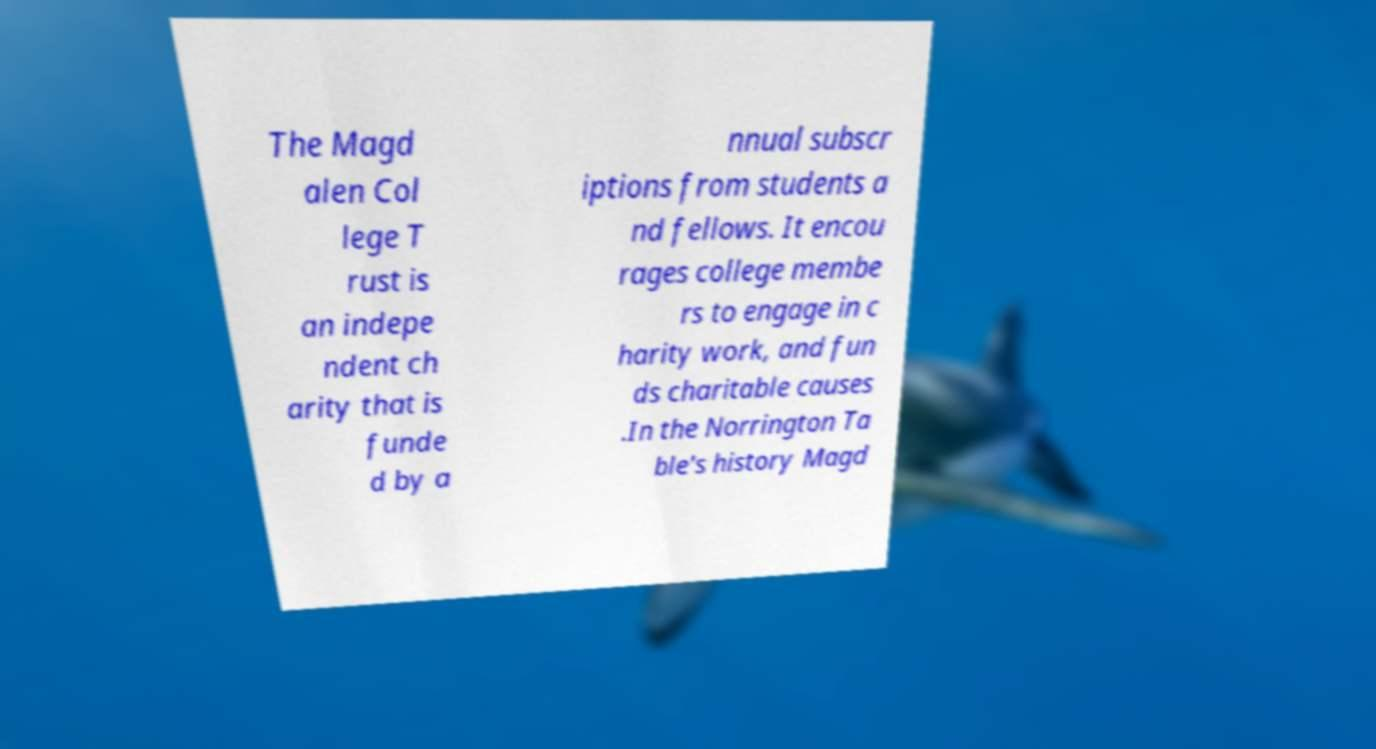Can you accurately transcribe the text from the provided image for me? The Magd alen Col lege T rust is an indepe ndent ch arity that is funde d by a nnual subscr iptions from students a nd fellows. It encou rages college membe rs to engage in c harity work, and fun ds charitable causes .In the Norrington Ta ble's history Magd 